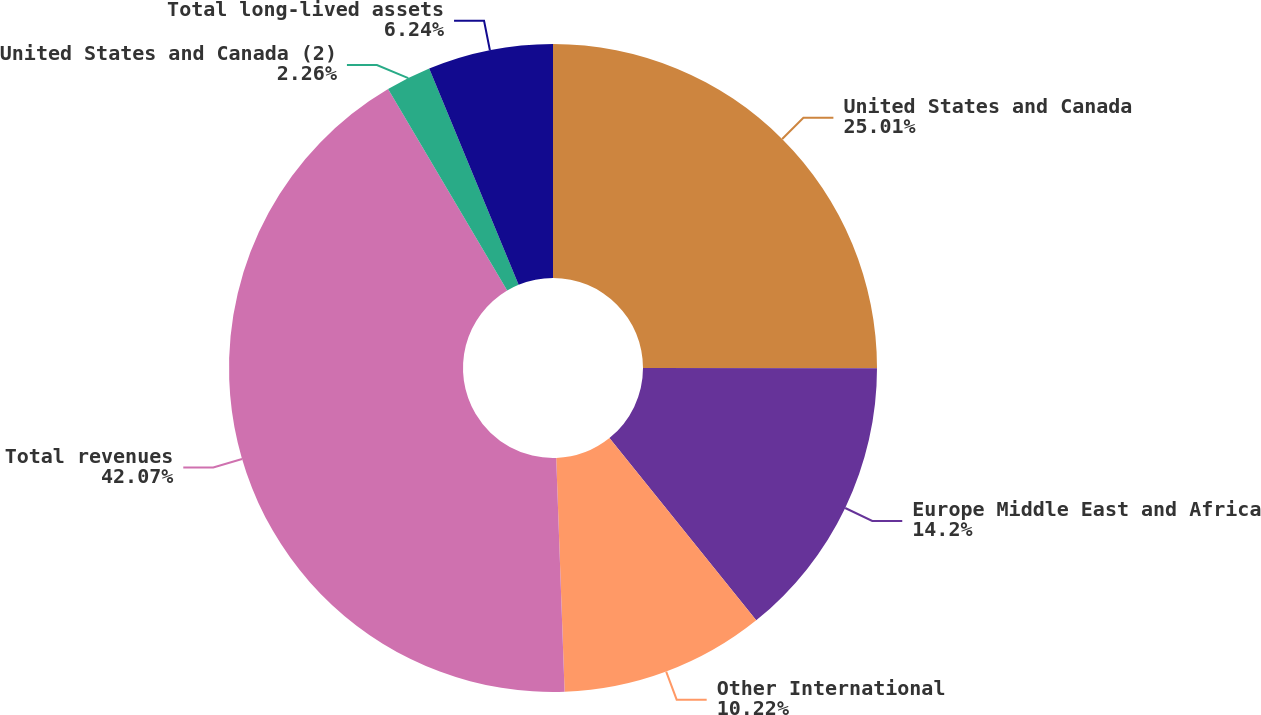<chart> <loc_0><loc_0><loc_500><loc_500><pie_chart><fcel>United States and Canada<fcel>Europe Middle East and Africa<fcel>Other International<fcel>Total revenues<fcel>United States and Canada (2)<fcel>Total long-lived assets<nl><fcel>25.01%<fcel>14.2%<fcel>10.22%<fcel>42.07%<fcel>2.26%<fcel>6.24%<nl></chart> 